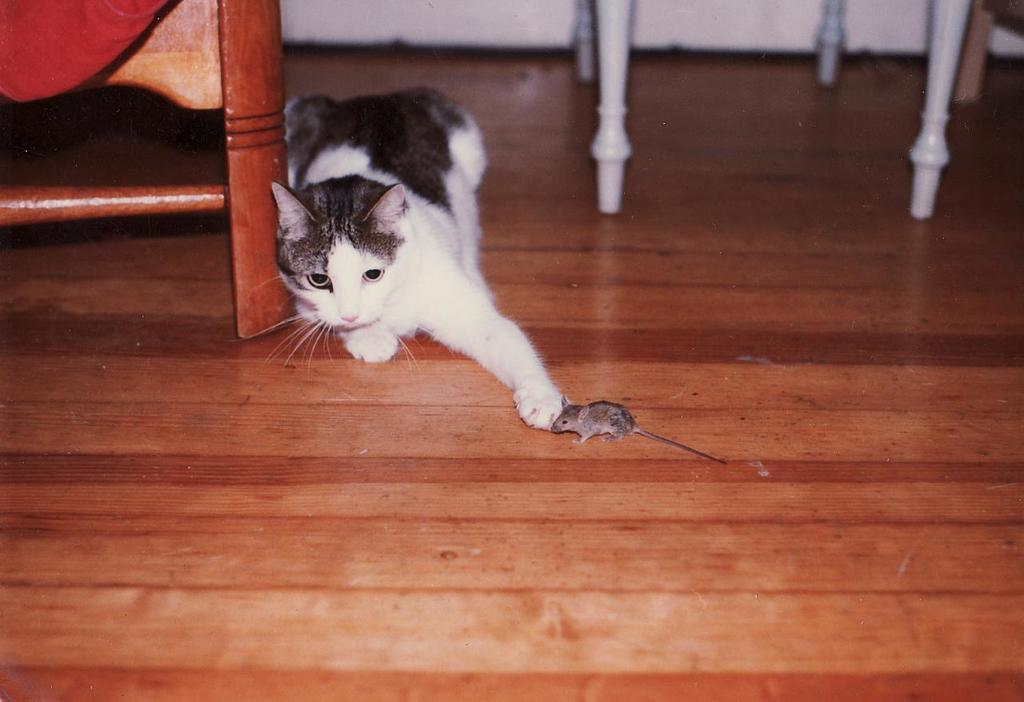What type of animal can be seen in the image? There is a cat in the image. What other animal is present in the image? There is a mouse in the image. What can be found on the floor in the image? There are wooden objects on the floor in the image. What type of collar can be seen on the van in the image? There is no van present in the image, and therefore no collar can be seen on a van. 